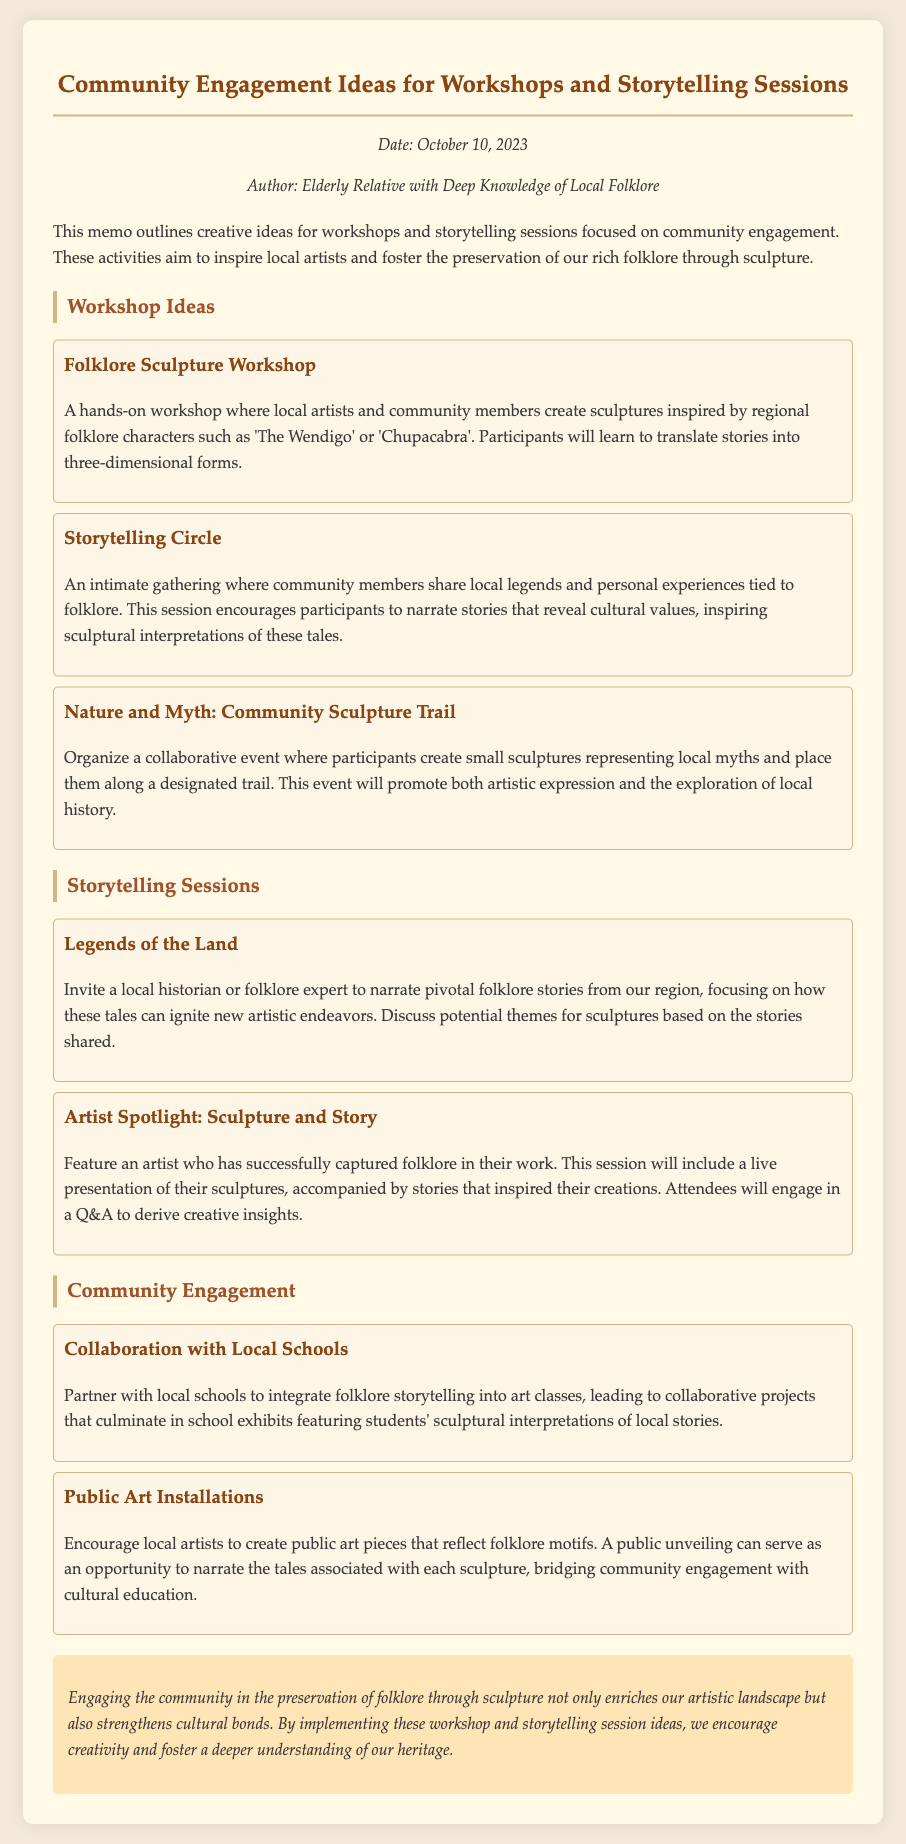what is the date of the memo? The date of the memo is stated in the meta section, which shows the date as October 10, 2023.
Answer: October 10, 2023 who is the author of the memo? The author of the memo is mentioned in the meta section, identified as "Elderly Relative with Deep Knowledge of Local Folklore."
Answer: Elderly Relative with Deep Knowledge of Local Folklore how many workshop ideas are listed? The workshop ideas section lists three different ideas, as indicated by the three distinct entries.
Answer: 3 what is the title of the sculpture workshop? The title of the sculpture workshop is provided in the workshops section, which is "Folklore Sculpture Workshop."
Answer: Folklore Sculpture Workshop what kind of collaboration is suggested with local schools? The memo suggests partnering with local schools to integrate folklore storytelling into art classes.
Answer: folklore storytelling into art classes what is the purpose of the "Legends of the Land" session? The purpose of the "Legends of the Land" session is to invite a local historian or folklore expert to narrate pivotal folklore stories from the region.
Answer: narrate pivotal folklore stories how does the memo describe the public art installations? The memo describes public art installations as creations that reflect folklore motifs intended for community engagement and cultural education.
Answer: reflect folklore motifs 